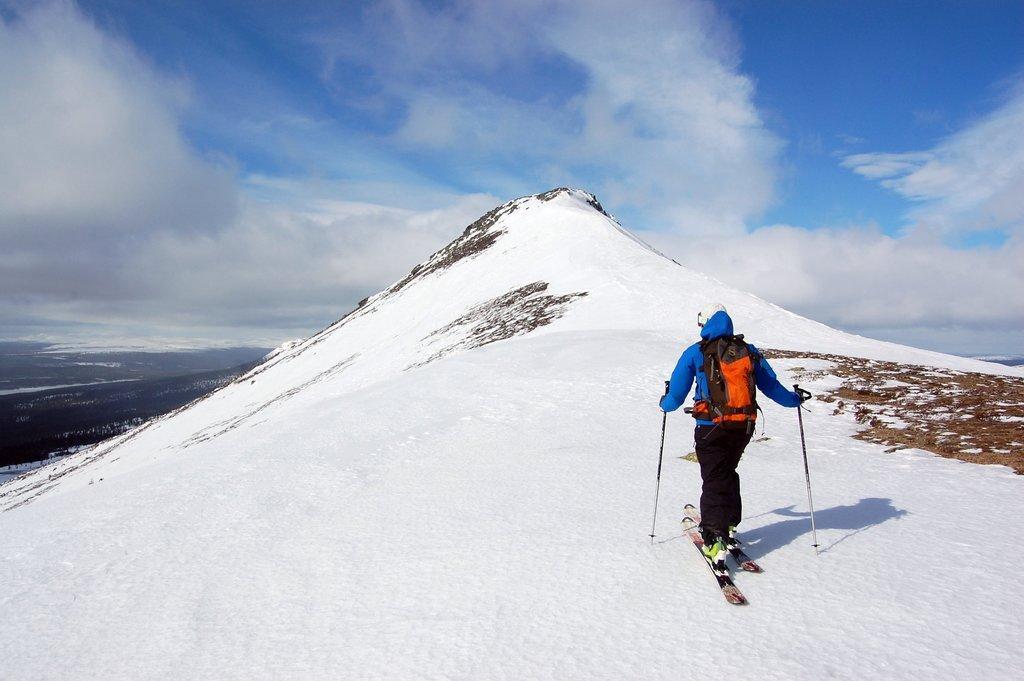Could you give a brief overview of what you see in this image? In this picture we can observe a person skiing on the skiing boards. He is skiing on the snow. He is holding two skiing sticks in his hands. The person is wearing blue color hoodie and an orange color bag on his shoulders. We can observe a hill covered with snow. In the background there is a sky with clouds. 